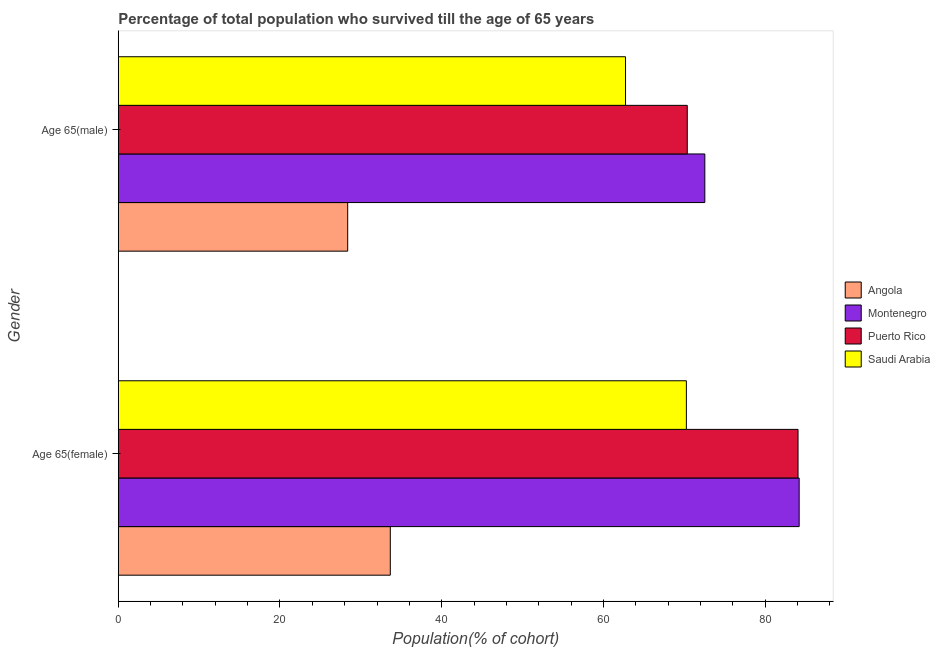How many different coloured bars are there?
Offer a terse response. 4. How many bars are there on the 1st tick from the bottom?
Your answer should be very brief. 4. What is the label of the 1st group of bars from the top?
Offer a terse response. Age 65(male). What is the percentage of female population who survived till age of 65 in Angola?
Ensure brevity in your answer.  33.64. Across all countries, what is the maximum percentage of male population who survived till age of 65?
Keep it short and to the point. 72.55. Across all countries, what is the minimum percentage of male population who survived till age of 65?
Offer a terse response. 28.37. In which country was the percentage of female population who survived till age of 65 maximum?
Your answer should be compact. Montenegro. In which country was the percentage of female population who survived till age of 65 minimum?
Make the answer very short. Angola. What is the total percentage of female population who survived till age of 65 in the graph?
Offer a very short reply. 272.2. What is the difference between the percentage of male population who survived till age of 65 in Montenegro and that in Saudi Arabia?
Make the answer very short. 9.81. What is the difference between the percentage of female population who survived till age of 65 in Montenegro and the percentage of male population who survived till age of 65 in Angola?
Provide a short and direct response. 55.84. What is the average percentage of male population who survived till age of 65 per country?
Offer a terse response. 58.51. What is the difference between the percentage of female population who survived till age of 65 and percentage of male population who survived till age of 65 in Puerto Rico?
Ensure brevity in your answer.  13.7. What is the ratio of the percentage of male population who survived till age of 65 in Angola to that in Montenegro?
Ensure brevity in your answer.  0.39. Is the percentage of female population who survived till age of 65 in Montenegro less than that in Puerto Rico?
Offer a very short reply. No. What does the 1st bar from the top in Age 65(female) represents?
Offer a very short reply. Saudi Arabia. What does the 2nd bar from the bottom in Age 65(female) represents?
Give a very brief answer. Montenegro. How many countries are there in the graph?
Offer a terse response. 4. Are the values on the major ticks of X-axis written in scientific E-notation?
Keep it short and to the point. No. How many legend labels are there?
Give a very brief answer. 4. How are the legend labels stacked?
Provide a short and direct response. Vertical. What is the title of the graph?
Ensure brevity in your answer.  Percentage of total population who survived till the age of 65 years. Does "Romania" appear as one of the legend labels in the graph?
Your response must be concise. No. What is the label or title of the X-axis?
Your response must be concise. Population(% of cohort). What is the Population(% of cohort) in Angola in Age 65(female)?
Provide a succinct answer. 33.64. What is the Population(% of cohort) of Montenegro in Age 65(female)?
Make the answer very short. 84.22. What is the Population(% of cohort) of Puerto Rico in Age 65(female)?
Provide a short and direct response. 84.08. What is the Population(% of cohort) of Saudi Arabia in Age 65(female)?
Keep it short and to the point. 70.27. What is the Population(% of cohort) in Angola in Age 65(male)?
Provide a succinct answer. 28.37. What is the Population(% of cohort) in Montenegro in Age 65(male)?
Provide a succinct answer. 72.55. What is the Population(% of cohort) in Puerto Rico in Age 65(male)?
Your answer should be very brief. 70.38. What is the Population(% of cohort) in Saudi Arabia in Age 65(male)?
Offer a very short reply. 62.74. Across all Gender, what is the maximum Population(% of cohort) in Angola?
Ensure brevity in your answer.  33.64. Across all Gender, what is the maximum Population(% of cohort) of Montenegro?
Your answer should be compact. 84.22. Across all Gender, what is the maximum Population(% of cohort) of Puerto Rico?
Offer a terse response. 84.08. Across all Gender, what is the maximum Population(% of cohort) of Saudi Arabia?
Your response must be concise. 70.27. Across all Gender, what is the minimum Population(% of cohort) in Angola?
Offer a very short reply. 28.37. Across all Gender, what is the minimum Population(% of cohort) in Montenegro?
Provide a succinct answer. 72.55. Across all Gender, what is the minimum Population(% of cohort) of Puerto Rico?
Your answer should be very brief. 70.38. Across all Gender, what is the minimum Population(% of cohort) in Saudi Arabia?
Ensure brevity in your answer.  62.74. What is the total Population(% of cohort) in Angola in the graph?
Provide a short and direct response. 62.02. What is the total Population(% of cohort) in Montenegro in the graph?
Give a very brief answer. 156.76. What is the total Population(% of cohort) of Puerto Rico in the graph?
Your response must be concise. 154.45. What is the total Population(% of cohort) of Saudi Arabia in the graph?
Your answer should be compact. 133. What is the difference between the Population(% of cohort) in Angola in Age 65(female) and that in Age 65(male)?
Your answer should be very brief. 5.27. What is the difference between the Population(% of cohort) in Montenegro in Age 65(female) and that in Age 65(male)?
Keep it short and to the point. 11.67. What is the difference between the Population(% of cohort) of Puerto Rico in Age 65(female) and that in Age 65(male)?
Your answer should be compact. 13.7. What is the difference between the Population(% of cohort) of Saudi Arabia in Age 65(female) and that in Age 65(male)?
Provide a succinct answer. 7.53. What is the difference between the Population(% of cohort) in Angola in Age 65(female) and the Population(% of cohort) in Montenegro in Age 65(male)?
Offer a very short reply. -38.9. What is the difference between the Population(% of cohort) in Angola in Age 65(female) and the Population(% of cohort) in Puerto Rico in Age 65(male)?
Keep it short and to the point. -36.73. What is the difference between the Population(% of cohort) in Angola in Age 65(female) and the Population(% of cohort) in Saudi Arabia in Age 65(male)?
Offer a terse response. -29.09. What is the difference between the Population(% of cohort) in Montenegro in Age 65(female) and the Population(% of cohort) in Puerto Rico in Age 65(male)?
Ensure brevity in your answer.  13.84. What is the difference between the Population(% of cohort) of Montenegro in Age 65(female) and the Population(% of cohort) of Saudi Arabia in Age 65(male)?
Provide a succinct answer. 21.48. What is the difference between the Population(% of cohort) of Puerto Rico in Age 65(female) and the Population(% of cohort) of Saudi Arabia in Age 65(male)?
Your answer should be compact. 21.34. What is the average Population(% of cohort) of Angola per Gender?
Offer a very short reply. 31.01. What is the average Population(% of cohort) in Montenegro per Gender?
Your answer should be very brief. 78.38. What is the average Population(% of cohort) of Puerto Rico per Gender?
Provide a succinct answer. 77.23. What is the average Population(% of cohort) in Saudi Arabia per Gender?
Offer a terse response. 66.5. What is the difference between the Population(% of cohort) of Angola and Population(% of cohort) of Montenegro in Age 65(female)?
Make the answer very short. -50.57. What is the difference between the Population(% of cohort) of Angola and Population(% of cohort) of Puerto Rico in Age 65(female)?
Give a very brief answer. -50.43. What is the difference between the Population(% of cohort) of Angola and Population(% of cohort) of Saudi Arabia in Age 65(female)?
Give a very brief answer. -36.62. What is the difference between the Population(% of cohort) of Montenegro and Population(% of cohort) of Puerto Rico in Age 65(female)?
Give a very brief answer. 0.14. What is the difference between the Population(% of cohort) of Montenegro and Population(% of cohort) of Saudi Arabia in Age 65(female)?
Give a very brief answer. 13.95. What is the difference between the Population(% of cohort) of Puerto Rico and Population(% of cohort) of Saudi Arabia in Age 65(female)?
Provide a short and direct response. 13.81. What is the difference between the Population(% of cohort) in Angola and Population(% of cohort) in Montenegro in Age 65(male)?
Your answer should be compact. -44.17. What is the difference between the Population(% of cohort) of Angola and Population(% of cohort) of Puerto Rico in Age 65(male)?
Provide a short and direct response. -42. What is the difference between the Population(% of cohort) of Angola and Population(% of cohort) of Saudi Arabia in Age 65(male)?
Provide a succinct answer. -34.36. What is the difference between the Population(% of cohort) of Montenegro and Population(% of cohort) of Puerto Rico in Age 65(male)?
Offer a very short reply. 2.17. What is the difference between the Population(% of cohort) of Montenegro and Population(% of cohort) of Saudi Arabia in Age 65(male)?
Give a very brief answer. 9.81. What is the difference between the Population(% of cohort) in Puerto Rico and Population(% of cohort) in Saudi Arabia in Age 65(male)?
Your answer should be compact. 7.64. What is the ratio of the Population(% of cohort) in Angola in Age 65(female) to that in Age 65(male)?
Ensure brevity in your answer.  1.19. What is the ratio of the Population(% of cohort) in Montenegro in Age 65(female) to that in Age 65(male)?
Your answer should be very brief. 1.16. What is the ratio of the Population(% of cohort) of Puerto Rico in Age 65(female) to that in Age 65(male)?
Provide a short and direct response. 1.19. What is the ratio of the Population(% of cohort) of Saudi Arabia in Age 65(female) to that in Age 65(male)?
Your response must be concise. 1.12. What is the difference between the highest and the second highest Population(% of cohort) in Angola?
Your answer should be compact. 5.27. What is the difference between the highest and the second highest Population(% of cohort) in Montenegro?
Give a very brief answer. 11.67. What is the difference between the highest and the second highest Population(% of cohort) of Puerto Rico?
Your answer should be compact. 13.7. What is the difference between the highest and the second highest Population(% of cohort) in Saudi Arabia?
Offer a very short reply. 7.53. What is the difference between the highest and the lowest Population(% of cohort) in Angola?
Provide a short and direct response. 5.27. What is the difference between the highest and the lowest Population(% of cohort) in Montenegro?
Provide a succinct answer. 11.67. What is the difference between the highest and the lowest Population(% of cohort) of Puerto Rico?
Your answer should be compact. 13.7. What is the difference between the highest and the lowest Population(% of cohort) of Saudi Arabia?
Provide a succinct answer. 7.53. 